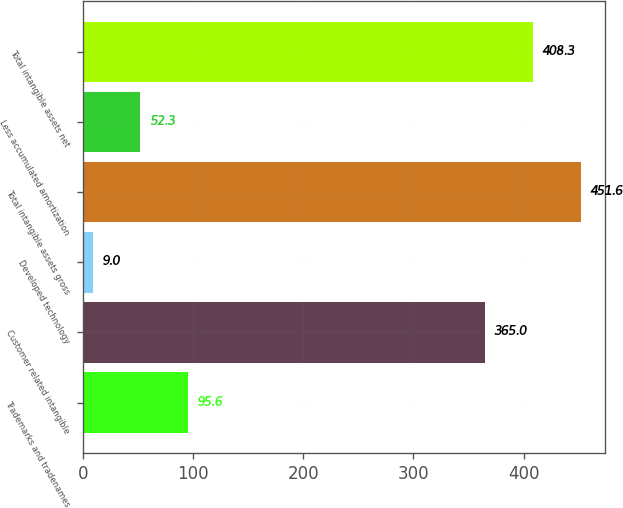<chart> <loc_0><loc_0><loc_500><loc_500><bar_chart><fcel>Trademarks and tradenames<fcel>Customer related intangible<fcel>Developed technology<fcel>Total intangible assets gross<fcel>Less accumulated amortization<fcel>Total intangible assets net<nl><fcel>95.6<fcel>365<fcel>9<fcel>451.6<fcel>52.3<fcel>408.3<nl></chart> 